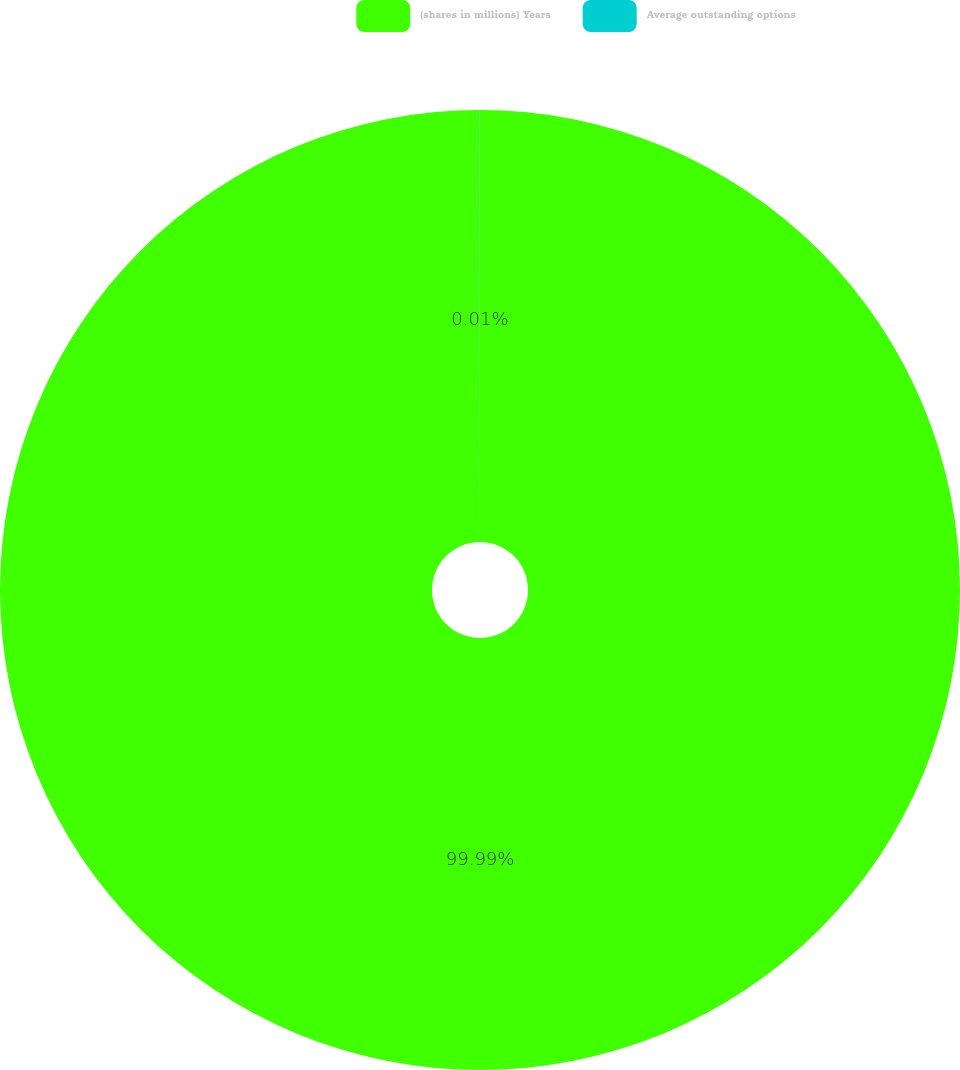Convert chart. <chart><loc_0><loc_0><loc_500><loc_500><pie_chart><fcel>(shares in millions) Years<fcel>Average outstanding options<nl><fcel>99.99%<fcel>0.01%<nl></chart> 